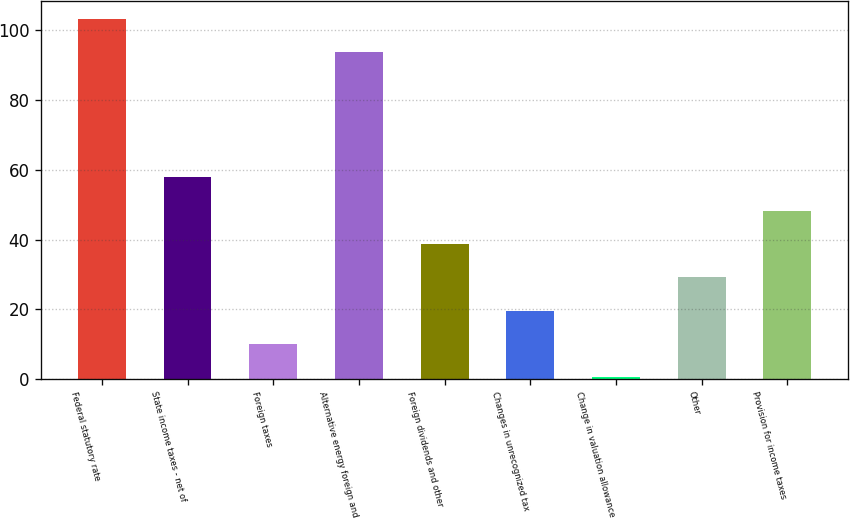Convert chart to OTSL. <chart><loc_0><loc_0><loc_500><loc_500><bar_chart><fcel>Federal statutory rate<fcel>State income taxes - net of<fcel>Foreign taxes<fcel>Alternative energy foreign and<fcel>Foreign dividends and other<fcel>Changes in unrecognized tax<fcel>Change in valuation allowance<fcel>Other<fcel>Provision for income taxes<nl><fcel>103.36<fcel>57.86<fcel>10.06<fcel>93.8<fcel>38.74<fcel>19.62<fcel>0.5<fcel>29.18<fcel>48.3<nl></chart> 